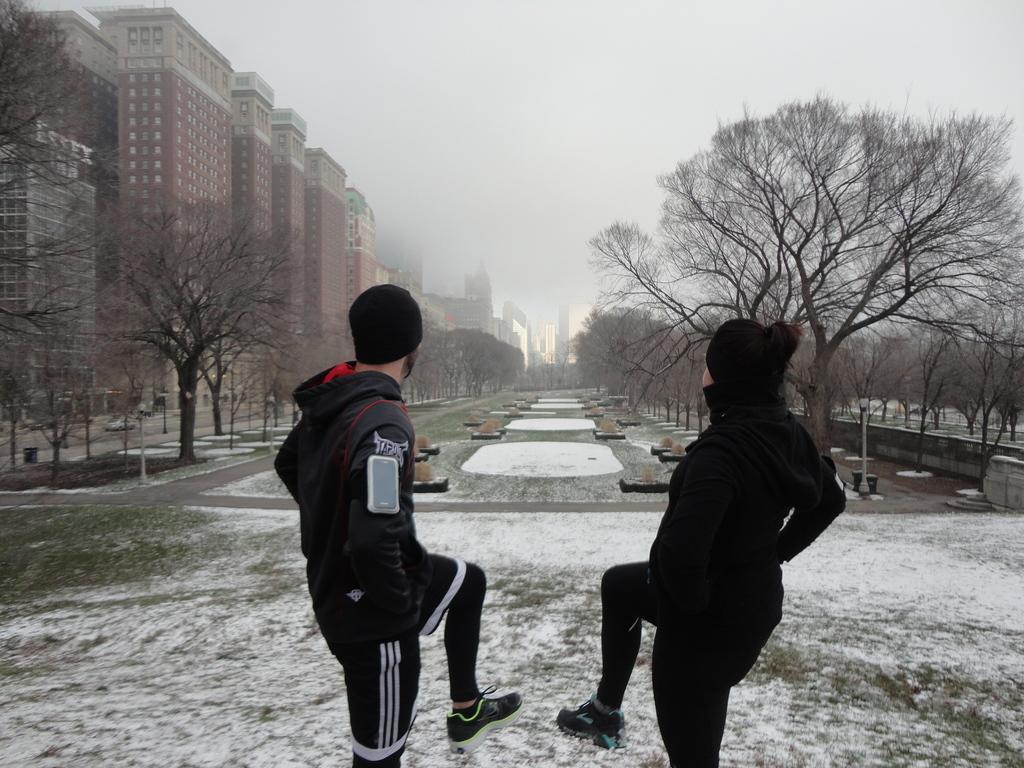In one or two sentences, can you explain what this image depicts? In this image I can see few buildings, windows, trees, snow, poles, sky and two people are standing. 